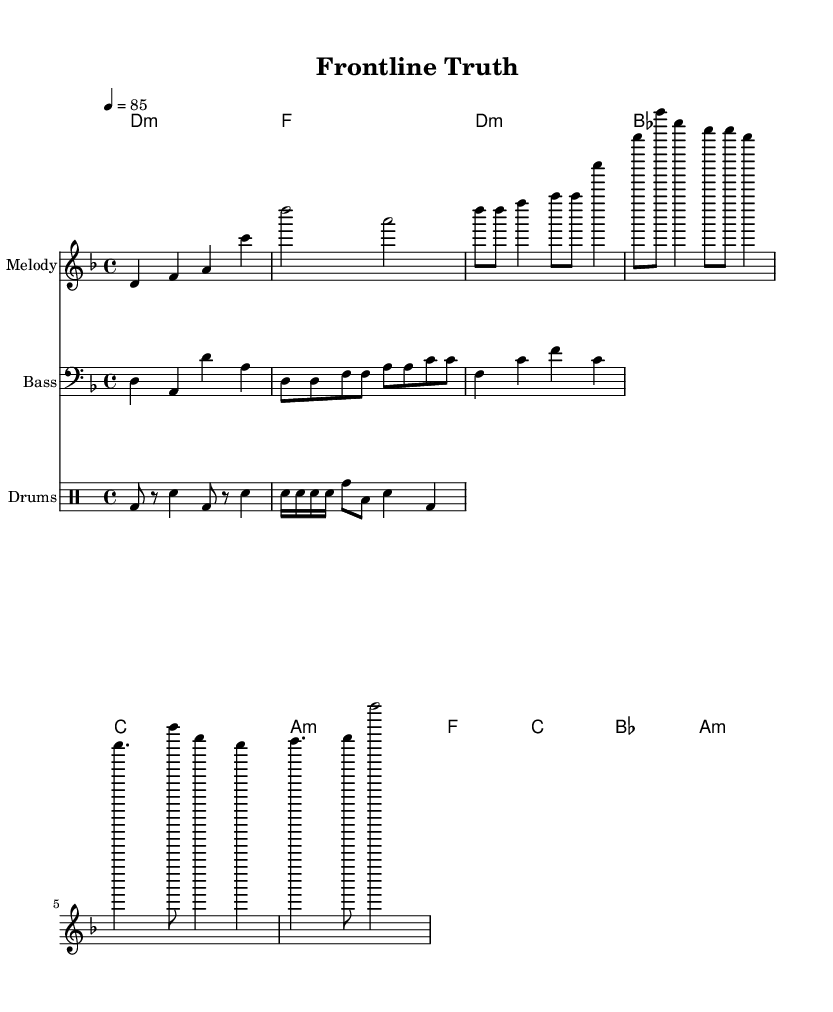What is the key signature of this music? The key signature is indicated at the beginning; it shows the notes that are sharp or flat. In this piece, there are no sharps or flats, therefore, it is in D minor, which has one flat.
Answer: D minor What is the time signature of this music? The time signature appears after the key signature and indicates how many beats are in each measure. Here, the time signature is 4/4, meaning there are four beats per measure.
Answer: 4/4 What is the tempo marking of this piece? The tempo marking is shown above the staff and indicates the speed of the piece. It is notated as "4 = 85," meaning there should be 85 beats per minute.
Answer: 85 How many measures are there in the verse? The verse contains a sequence of notes organized into measures. Counting the measures in the specified verse section, there are five measures in total.
Answer: 5 What is the primary genre of this piece? The genre style is often indicated by the instrumentation and rhythm type represented in the music. This is a hip-hop piece, characterized by its rhythmic structure and lyrical flow typical of rap.
Answer: Hip-hop In which section does the key change occur? To determine if a key change occurs, one would examine the harmonies presented in the various parts of the music. Here, the harmonies remain consistent throughout the intro, verse, and chorus without modulation to a new key.
Answer: No key change 